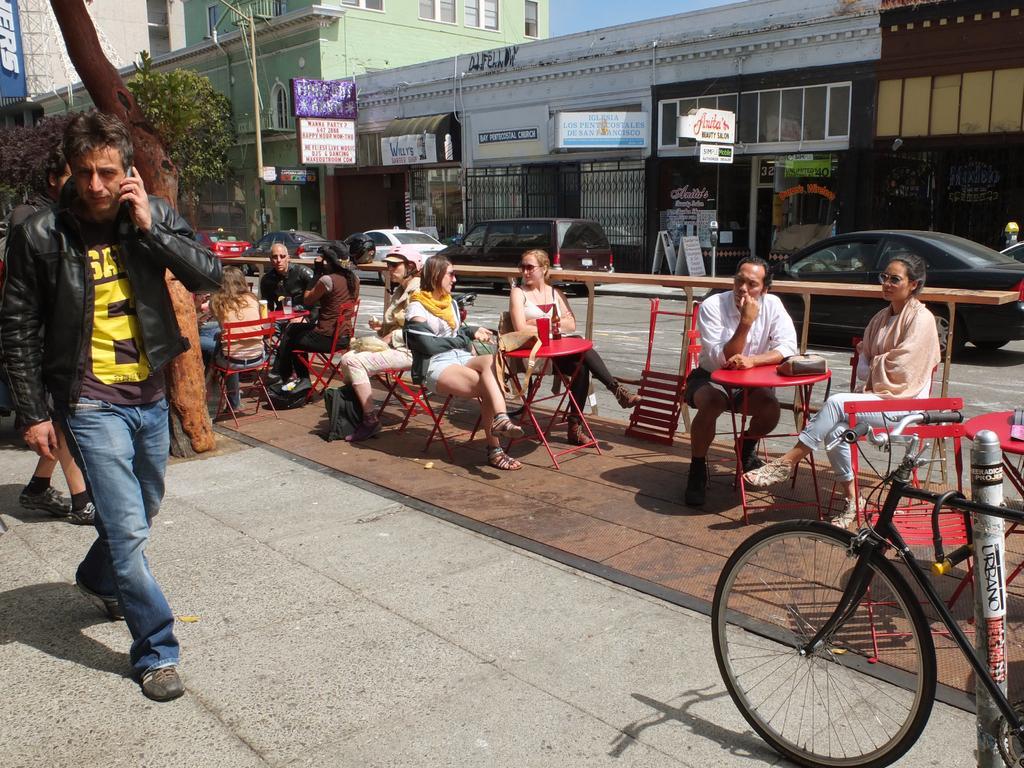How would you summarize this image in a sentence or two? As we can see in the image, there is a tree, buildings, poster, banner, a man standing on road and few people sitting on chairs and on road there are cars. 